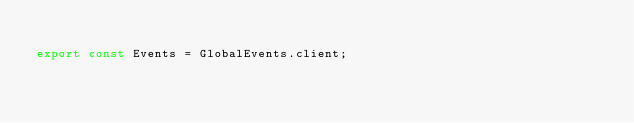<code> <loc_0><loc_0><loc_500><loc_500><_TypeScript_>
export const Events = GlobalEvents.client;
</code> 